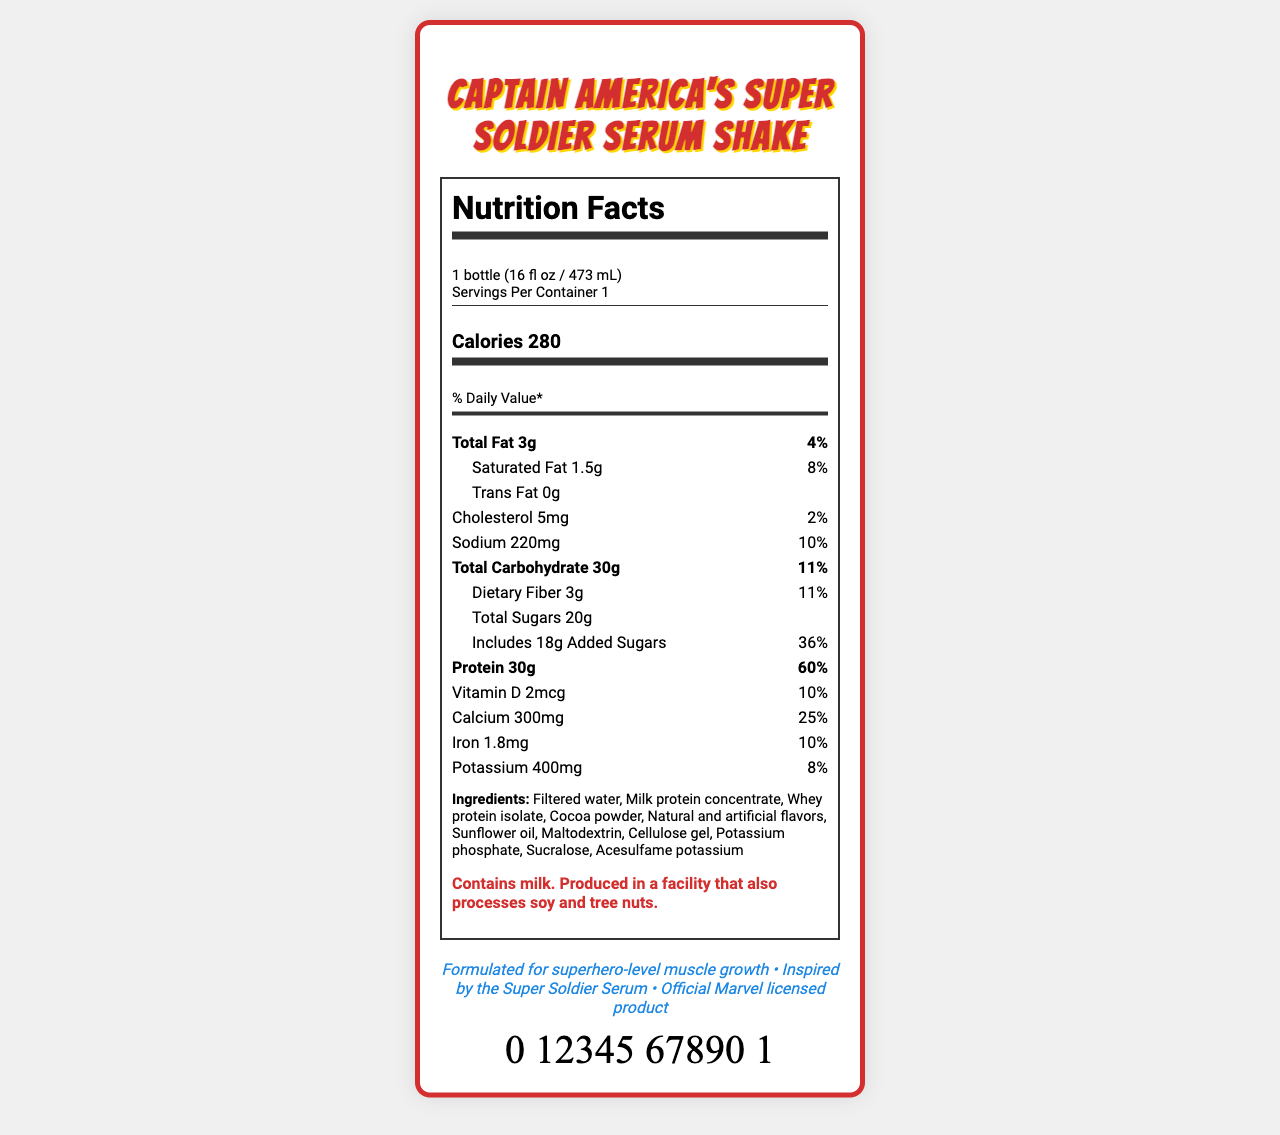What is the serving size of the Captain America's Super Soldier Serum Shake? The serving size is clearly stated in the document as "1 bottle (16 fl oz / 473 mL)".
Answer: 1 bottle (16 fl oz / 473 mL) How many calories are in a serving of this shake? The calories per serving are listed as 280 on the document.
Answer: 280 What is the total amount of protein in one serving? The document lists protein content as 30g.
Answer: 30g What percentage of the daily value for added sugars does this shake provide? The document states that the added sugars amount to 36% of the daily value.
Answer: 36% Which company manufactures this protein shake? The manufacturer is listed as Stark Industries Nutrition in the document.
Answer: Stark Industries Nutrition What is the total fat content in a serving of the shake? The total fat content in a single serving is listed as 3g.
Answer: 3g What are the allergens present in this shake? A. Soy B. Milk C. Tree nuts D. All of the above The allergen information states that the shake contains milk and is produced in a facility that processes soy and tree nuts.
Answer: D. All of the above What is the daily value percentage of calcium provided by this shake? A. 10% B. 20% C. 25% D. 30% The document shows that the daily value percentage for calcium is 25%.
Answer: C. 25% How many grams of dietary fiber are included in each serving of the shake? The document mentions that the dietary fiber content is 3g.
Answer: 3g Does this product contain any trans fat? The document explicitly states that the trans fat content is "0g".
Answer: No Summarize the key points of the nutrition label for Captain America's Super Soldier Serum Shake. This summary includes the main nutritional details like calories, macronutrients, and key vitamins and minerals. It also highlights manufacturer and allergen information.
Answer: The Captain America's Super Soldier Serum Shake is a high-protein drink with 280 calories per serving. It contains 3g of total fat, 30g of carbs, and 30g of protein. Key nutrients include calcium (25% DV) and added sugars (36% DV). It's marketed by Stark Industries Nutrition and is exclusive to Avengers Comics & Collectibles. The allergen information mentions it contains milk and may have traces of soy and tree nuts. Which superhero is this protein shake inspired by? The product name is "Captain America's Super Soldier Serum Shake", indicating its inspiration.
Answer: Captain America Is this shake exclusive to any particular distributor? The shake is exclusively distributed by Avengers Comics & Collectibles.
Answer: Yes Does this shake contain more saturated fat or cholesterol? The shake contains 1.5g of saturated fat compared to 5mg of cholesterol.
Answer: Saturated fat What flavoring agents are used in this shake? The ingredients list includes "Natural and artificial flavors".
Answer: Natural and artificial flavors Who is responsible for the distribution of this protein shake? The document states that distribution is exclusive to Avengers Comics & Collectibles.
Answer: Avengers Comics & Collectibles What is the barcode of this product? The barcode displayed in the document is 0 12345 67890 1.
Answer: 0 12345 67890 1 How much potassium is there in one serving? The document states that one serving contains 400mg of potassium.
Answer: 400mg Can we determine the price of this protein shake from the document? The document does not provide any details about the price of the protein shake.
Answer: Not enough information 